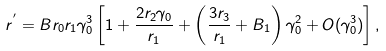<formula> <loc_0><loc_0><loc_500><loc_500>r ^ { ^ { \prime } } = B r _ { 0 } r _ { 1 } \gamma _ { 0 } ^ { 3 } \left [ 1 + \frac { 2 r _ { 2 } \gamma _ { 0 } } { r _ { 1 } } + \left ( \frac { 3 r _ { 3 } } { r _ { 1 } } + B _ { 1 } \right ) \gamma _ { 0 } ^ { 2 } + O ( \gamma _ { 0 } ^ { 3 } ) \right ] ,</formula> 